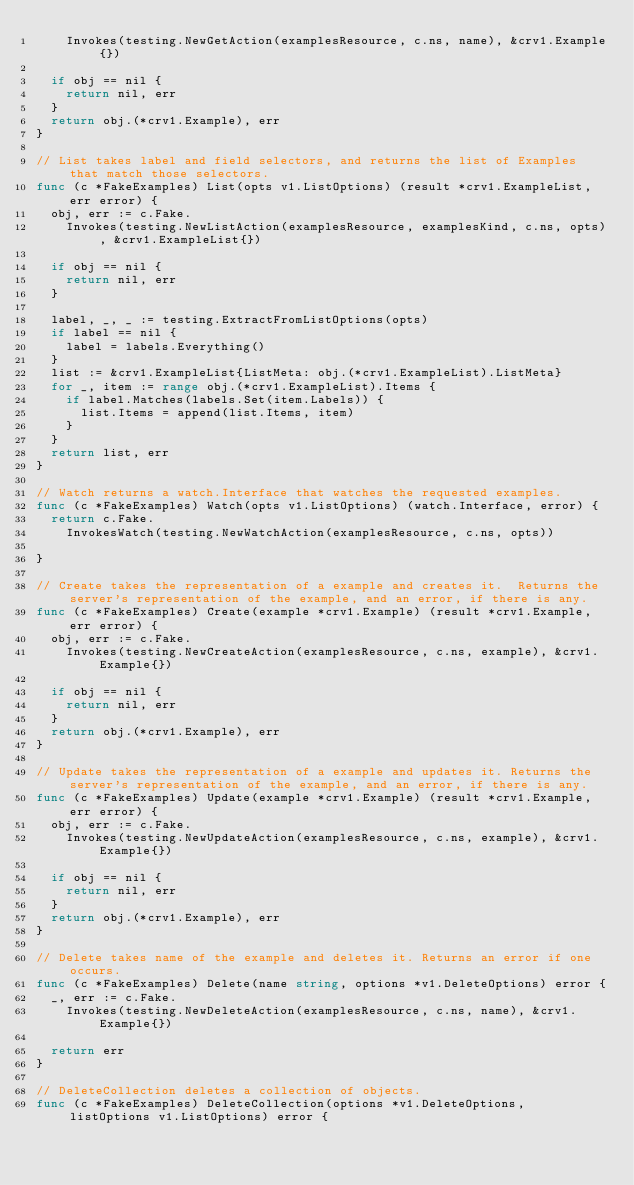<code> <loc_0><loc_0><loc_500><loc_500><_Go_>		Invokes(testing.NewGetAction(examplesResource, c.ns, name), &crv1.Example{})

	if obj == nil {
		return nil, err
	}
	return obj.(*crv1.Example), err
}

// List takes label and field selectors, and returns the list of Examples that match those selectors.
func (c *FakeExamples) List(opts v1.ListOptions) (result *crv1.ExampleList, err error) {
	obj, err := c.Fake.
		Invokes(testing.NewListAction(examplesResource, examplesKind, c.ns, opts), &crv1.ExampleList{})

	if obj == nil {
		return nil, err
	}

	label, _, _ := testing.ExtractFromListOptions(opts)
	if label == nil {
		label = labels.Everything()
	}
	list := &crv1.ExampleList{ListMeta: obj.(*crv1.ExampleList).ListMeta}
	for _, item := range obj.(*crv1.ExampleList).Items {
		if label.Matches(labels.Set(item.Labels)) {
			list.Items = append(list.Items, item)
		}
	}
	return list, err
}

// Watch returns a watch.Interface that watches the requested examples.
func (c *FakeExamples) Watch(opts v1.ListOptions) (watch.Interface, error) {
	return c.Fake.
		InvokesWatch(testing.NewWatchAction(examplesResource, c.ns, opts))

}

// Create takes the representation of a example and creates it.  Returns the server's representation of the example, and an error, if there is any.
func (c *FakeExamples) Create(example *crv1.Example) (result *crv1.Example, err error) {
	obj, err := c.Fake.
		Invokes(testing.NewCreateAction(examplesResource, c.ns, example), &crv1.Example{})

	if obj == nil {
		return nil, err
	}
	return obj.(*crv1.Example), err
}

// Update takes the representation of a example and updates it. Returns the server's representation of the example, and an error, if there is any.
func (c *FakeExamples) Update(example *crv1.Example) (result *crv1.Example, err error) {
	obj, err := c.Fake.
		Invokes(testing.NewUpdateAction(examplesResource, c.ns, example), &crv1.Example{})

	if obj == nil {
		return nil, err
	}
	return obj.(*crv1.Example), err
}

// Delete takes name of the example and deletes it. Returns an error if one occurs.
func (c *FakeExamples) Delete(name string, options *v1.DeleteOptions) error {
	_, err := c.Fake.
		Invokes(testing.NewDeleteAction(examplesResource, c.ns, name), &crv1.Example{})

	return err
}

// DeleteCollection deletes a collection of objects.
func (c *FakeExamples) DeleteCollection(options *v1.DeleteOptions, listOptions v1.ListOptions) error {</code> 